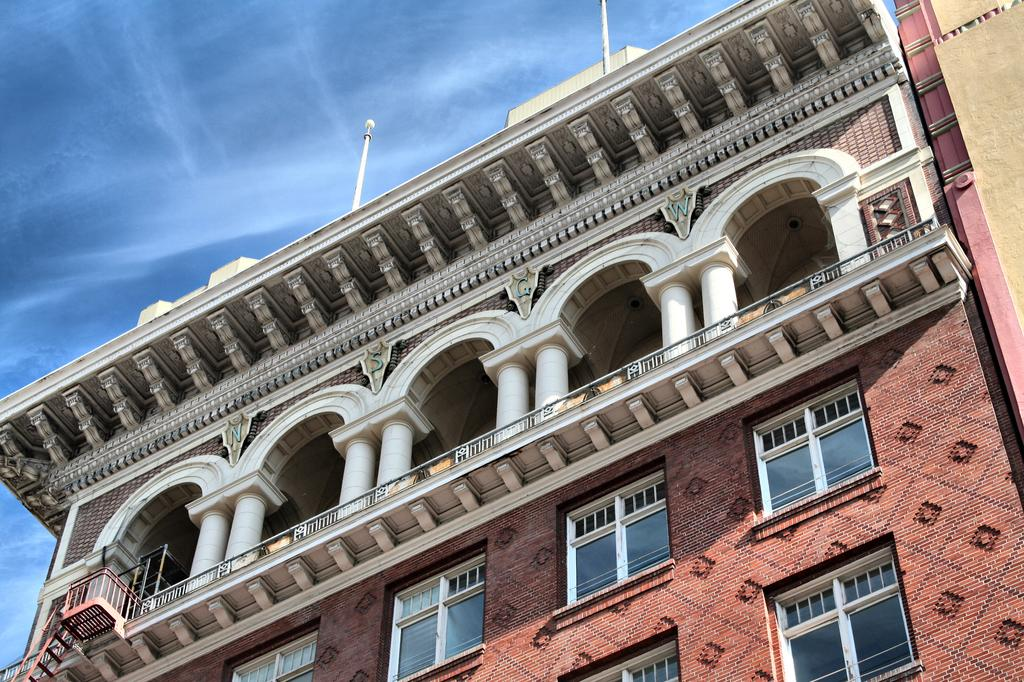What type of structure is present in the image? There is a building in the image. What architectural features can be seen on the building? The building has pillars, arches, railings, and windows. Are there any additional elements on top of the building? Yes, there are poles on top of the building. What can be seen in the background of the image? The sky is visible in the image. Can you tell me how many knees are visible in the image? There are no knees visible in the image; it features a building with various architectural elements. Are there any animals from a zoo present in the image? There are no animals or references to a zoo in the image; it features a building with architectural elements and the sky in the background. 